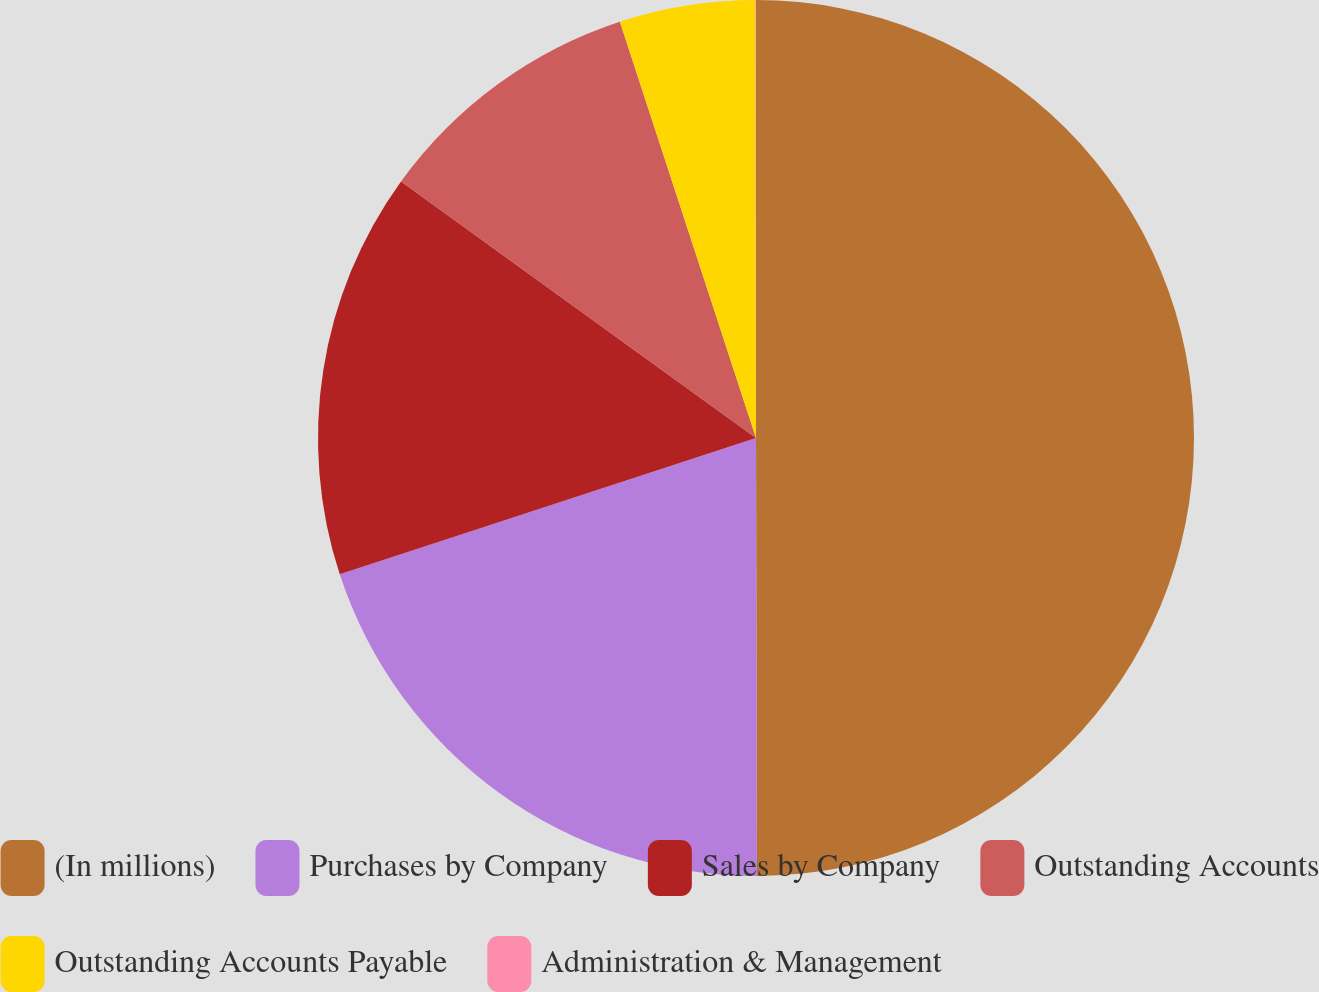Convert chart to OTSL. <chart><loc_0><loc_0><loc_500><loc_500><pie_chart><fcel>(In millions)<fcel>Purchases by Company<fcel>Sales by Company<fcel>Outstanding Accounts<fcel>Outstanding Accounts Payable<fcel>Administration & Management<nl><fcel>49.97%<fcel>20.0%<fcel>15.0%<fcel>10.01%<fcel>5.01%<fcel>0.02%<nl></chart> 